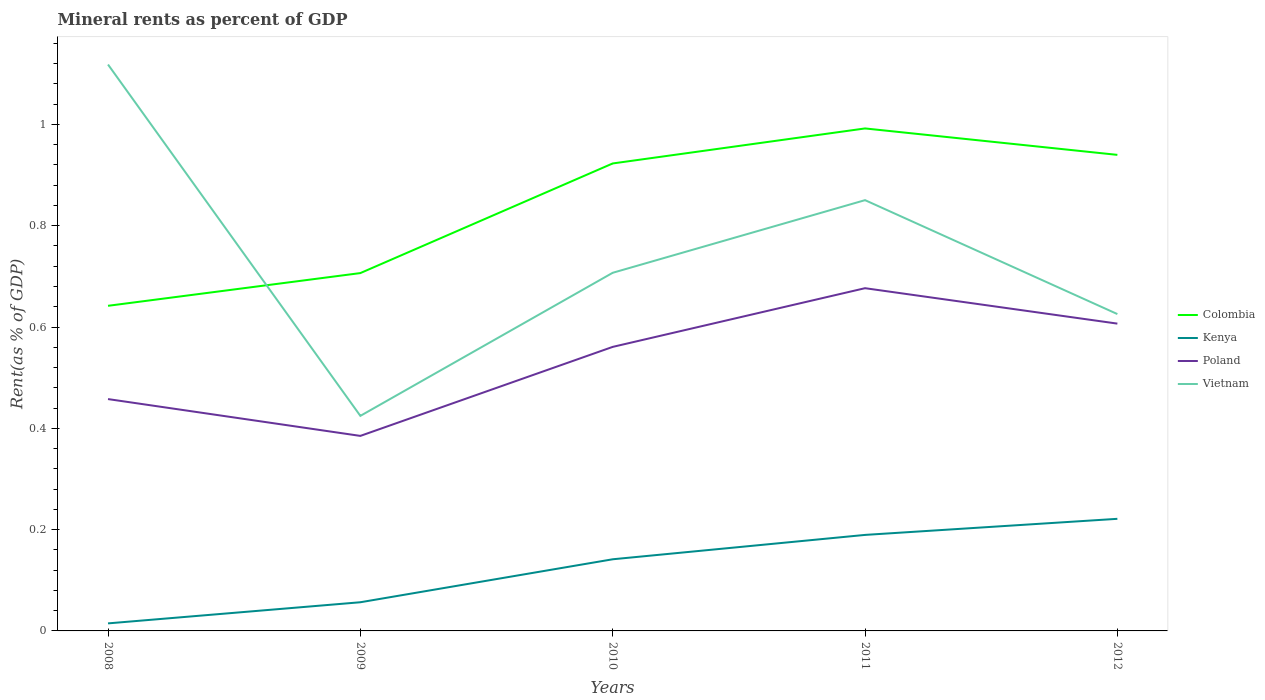How many different coloured lines are there?
Your answer should be compact. 4. Is the number of lines equal to the number of legend labels?
Give a very brief answer. Yes. Across all years, what is the maximum mineral rent in Poland?
Give a very brief answer. 0.39. What is the total mineral rent in Poland in the graph?
Make the answer very short. -0.29. What is the difference between the highest and the second highest mineral rent in Vietnam?
Provide a succinct answer. 0.69. How many years are there in the graph?
Provide a short and direct response. 5. Does the graph contain any zero values?
Keep it short and to the point. No. How many legend labels are there?
Offer a very short reply. 4. How are the legend labels stacked?
Offer a terse response. Vertical. What is the title of the graph?
Make the answer very short. Mineral rents as percent of GDP. Does "United Kingdom" appear as one of the legend labels in the graph?
Your answer should be compact. No. What is the label or title of the Y-axis?
Give a very brief answer. Rent(as % of GDP). What is the Rent(as % of GDP) of Colombia in 2008?
Keep it short and to the point. 0.64. What is the Rent(as % of GDP) of Kenya in 2008?
Give a very brief answer. 0.01. What is the Rent(as % of GDP) of Poland in 2008?
Provide a short and direct response. 0.46. What is the Rent(as % of GDP) of Vietnam in 2008?
Keep it short and to the point. 1.12. What is the Rent(as % of GDP) of Colombia in 2009?
Your answer should be compact. 0.71. What is the Rent(as % of GDP) of Kenya in 2009?
Your answer should be very brief. 0.06. What is the Rent(as % of GDP) of Poland in 2009?
Offer a terse response. 0.39. What is the Rent(as % of GDP) of Vietnam in 2009?
Offer a very short reply. 0.42. What is the Rent(as % of GDP) in Colombia in 2010?
Provide a short and direct response. 0.92. What is the Rent(as % of GDP) in Kenya in 2010?
Offer a very short reply. 0.14. What is the Rent(as % of GDP) of Poland in 2010?
Make the answer very short. 0.56. What is the Rent(as % of GDP) in Vietnam in 2010?
Make the answer very short. 0.71. What is the Rent(as % of GDP) in Colombia in 2011?
Provide a short and direct response. 0.99. What is the Rent(as % of GDP) in Kenya in 2011?
Make the answer very short. 0.19. What is the Rent(as % of GDP) of Poland in 2011?
Give a very brief answer. 0.68. What is the Rent(as % of GDP) in Vietnam in 2011?
Offer a terse response. 0.85. What is the Rent(as % of GDP) in Colombia in 2012?
Give a very brief answer. 0.94. What is the Rent(as % of GDP) in Kenya in 2012?
Your answer should be very brief. 0.22. What is the Rent(as % of GDP) in Poland in 2012?
Your response must be concise. 0.61. What is the Rent(as % of GDP) of Vietnam in 2012?
Your answer should be compact. 0.63. Across all years, what is the maximum Rent(as % of GDP) in Colombia?
Ensure brevity in your answer.  0.99. Across all years, what is the maximum Rent(as % of GDP) of Kenya?
Make the answer very short. 0.22. Across all years, what is the maximum Rent(as % of GDP) of Poland?
Ensure brevity in your answer.  0.68. Across all years, what is the maximum Rent(as % of GDP) in Vietnam?
Your response must be concise. 1.12. Across all years, what is the minimum Rent(as % of GDP) in Colombia?
Provide a short and direct response. 0.64. Across all years, what is the minimum Rent(as % of GDP) of Kenya?
Provide a short and direct response. 0.01. Across all years, what is the minimum Rent(as % of GDP) of Poland?
Give a very brief answer. 0.39. Across all years, what is the minimum Rent(as % of GDP) in Vietnam?
Offer a very short reply. 0.42. What is the total Rent(as % of GDP) of Colombia in the graph?
Offer a terse response. 4.2. What is the total Rent(as % of GDP) of Kenya in the graph?
Offer a terse response. 0.62. What is the total Rent(as % of GDP) in Poland in the graph?
Offer a very short reply. 2.69. What is the total Rent(as % of GDP) of Vietnam in the graph?
Your answer should be very brief. 3.73. What is the difference between the Rent(as % of GDP) of Colombia in 2008 and that in 2009?
Your response must be concise. -0.06. What is the difference between the Rent(as % of GDP) of Kenya in 2008 and that in 2009?
Offer a very short reply. -0.04. What is the difference between the Rent(as % of GDP) in Poland in 2008 and that in 2009?
Your answer should be very brief. 0.07. What is the difference between the Rent(as % of GDP) of Vietnam in 2008 and that in 2009?
Keep it short and to the point. 0.69. What is the difference between the Rent(as % of GDP) of Colombia in 2008 and that in 2010?
Keep it short and to the point. -0.28. What is the difference between the Rent(as % of GDP) in Kenya in 2008 and that in 2010?
Offer a terse response. -0.13. What is the difference between the Rent(as % of GDP) in Poland in 2008 and that in 2010?
Offer a very short reply. -0.1. What is the difference between the Rent(as % of GDP) of Vietnam in 2008 and that in 2010?
Ensure brevity in your answer.  0.41. What is the difference between the Rent(as % of GDP) in Colombia in 2008 and that in 2011?
Offer a very short reply. -0.35. What is the difference between the Rent(as % of GDP) in Kenya in 2008 and that in 2011?
Offer a terse response. -0.17. What is the difference between the Rent(as % of GDP) of Poland in 2008 and that in 2011?
Offer a very short reply. -0.22. What is the difference between the Rent(as % of GDP) in Vietnam in 2008 and that in 2011?
Your answer should be very brief. 0.27. What is the difference between the Rent(as % of GDP) in Colombia in 2008 and that in 2012?
Offer a very short reply. -0.3. What is the difference between the Rent(as % of GDP) of Kenya in 2008 and that in 2012?
Ensure brevity in your answer.  -0.21. What is the difference between the Rent(as % of GDP) of Poland in 2008 and that in 2012?
Offer a very short reply. -0.15. What is the difference between the Rent(as % of GDP) in Vietnam in 2008 and that in 2012?
Offer a very short reply. 0.49. What is the difference between the Rent(as % of GDP) of Colombia in 2009 and that in 2010?
Give a very brief answer. -0.22. What is the difference between the Rent(as % of GDP) in Kenya in 2009 and that in 2010?
Ensure brevity in your answer.  -0.08. What is the difference between the Rent(as % of GDP) in Poland in 2009 and that in 2010?
Ensure brevity in your answer.  -0.18. What is the difference between the Rent(as % of GDP) of Vietnam in 2009 and that in 2010?
Provide a short and direct response. -0.28. What is the difference between the Rent(as % of GDP) in Colombia in 2009 and that in 2011?
Ensure brevity in your answer.  -0.29. What is the difference between the Rent(as % of GDP) of Kenya in 2009 and that in 2011?
Offer a very short reply. -0.13. What is the difference between the Rent(as % of GDP) in Poland in 2009 and that in 2011?
Offer a terse response. -0.29. What is the difference between the Rent(as % of GDP) of Vietnam in 2009 and that in 2011?
Provide a succinct answer. -0.43. What is the difference between the Rent(as % of GDP) of Colombia in 2009 and that in 2012?
Provide a short and direct response. -0.23. What is the difference between the Rent(as % of GDP) in Kenya in 2009 and that in 2012?
Give a very brief answer. -0.16. What is the difference between the Rent(as % of GDP) of Poland in 2009 and that in 2012?
Keep it short and to the point. -0.22. What is the difference between the Rent(as % of GDP) of Vietnam in 2009 and that in 2012?
Offer a terse response. -0.2. What is the difference between the Rent(as % of GDP) of Colombia in 2010 and that in 2011?
Give a very brief answer. -0.07. What is the difference between the Rent(as % of GDP) of Kenya in 2010 and that in 2011?
Your answer should be very brief. -0.05. What is the difference between the Rent(as % of GDP) of Poland in 2010 and that in 2011?
Keep it short and to the point. -0.12. What is the difference between the Rent(as % of GDP) of Vietnam in 2010 and that in 2011?
Offer a terse response. -0.14. What is the difference between the Rent(as % of GDP) in Colombia in 2010 and that in 2012?
Keep it short and to the point. -0.02. What is the difference between the Rent(as % of GDP) in Kenya in 2010 and that in 2012?
Offer a very short reply. -0.08. What is the difference between the Rent(as % of GDP) of Poland in 2010 and that in 2012?
Your answer should be compact. -0.05. What is the difference between the Rent(as % of GDP) of Vietnam in 2010 and that in 2012?
Your response must be concise. 0.08. What is the difference between the Rent(as % of GDP) of Colombia in 2011 and that in 2012?
Your answer should be very brief. 0.05. What is the difference between the Rent(as % of GDP) in Kenya in 2011 and that in 2012?
Keep it short and to the point. -0.03. What is the difference between the Rent(as % of GDP) of Poland in 2011 and that in 2012?
Offer a very short reply. 0.07. What is the difference between the Rent(as % of GDP) of Vietnam in 2011 and that in 2012?
Offer a very short reply. 0.22. What is the difference between the Rent(as % of GDP) in Colombia in 2008 and the Rent(as % of GDP) in Kenya in 2009?
Your answer should be compact. 0.59. What is the difference between the Rent(as % of GDP) in Colombia in 2008 and the Rent(as % of GDP) in Poland in 2009?
Provide a succinct answer. 0.26. What is the difference between the Rent(as % of GDP) of Colombia in 2008 and the Rent(as % of GDP) of Vietnam in 2009?
Offer a terse response. 0.22. What is the difference between the Rent(as % of GDP) in Kenya in 2008 and the Rent(as % of GDP) in Poland in 2009?
Your answer should be very brief. -0.37. What is the difference between the Rent(as % of GDP) in Kenya in 2008 and the Rent(as % of GDP) in Vietnam in 2009?
Provide a succinct answer. -0.41. What is the difference between the Rent(as % of GDP) in Poland in 2008 and the Rent(as % of GDP) in Vietnam in 2009?
Your answer should be compact. 0.03. What is the difference between the Rent(as % of GDP) in Colombia in 2008 and the Rent(as % of GDP) in Kenya in 2010?
Your answer should be compact. 0.5. What is the difference between the Rent(as % of GDP) in Colombia in 2008 and the Rent(as % of GDP) in Poland in 2010?
Give a very brief answer. 0.08. What is the difference between the Rent(as % of GDP) of Colombia in 2008 and the Rent(as % of GDP) of Vietnam in 2010?
Keep it short and to the point. -0.07. What is the difference between the Rent(as % of GDP) in Kenya in 2008 and the Rent(as % of GDP) in Poland in 2010?
Give a very brief answer. -0.55. What is the difference between the Rent(as % of GDP) in Kenya in 2008 and the Rent(as % of GDP) in Vietnam in 2010?
Your answer should be very brief. -0.69. What is the difference between the Rent(as % of GDP) of Poland in 2008 and the Rent(as % of GDP) of Vietnam in 2010?
Provide a short and direct response. -0.25. What is the difference between the Rent(as % of GDP) in Colombia in 2008 and the Rent(as % of GDP) in Kenya in 2011?
Ensure brevity in your answer.  0.45. What is the difference between the Rent(as % of GDP) in Colombia in 2008 and the Rent(as % of GDP) in Poland in 2011?
Offer a very short reply. -0.03. What is the difference between the Rent(as % of GDP) of Colombia in 2008 and the Rent(as % of GDP) of Vietnam in 2011?
Your answer should be very brief. -0.21. What is the difference between the Rent(as % of GDP) in Kenya in 2008 and the Rent(as % of GDP) in Poland in 2011?
Your response must be concise. -0.66. What is the difference between the Rent(as % of GDP) of Kenya in 2008 and the Rent(as % of GDP) of Vietnam in 2011?
Give a very brief answer. -0.84. What is the difference between the Rent(as % of GDP) in Poland in 2008 and the Rent(as % of GDP) in Vietnam in 2011?
Your answer should be compact. -0.39. What is the difference between the Rent(as % of GDP) in Colombia in 2008 and the Rent(as % of GDP) in Kenya in 2012?
Make the answer very short. 0.42. What is the difference between the Rent(as % of GDP) of Colombia in 2008 and the Rent(as % of GDP) of Poland in 2012?
Make the answer very short. 0.04. What is the difference between the Rent(as % of GDP) of Colombia in 2008 and the Rent(as % of GDP) of Vietnam in 2012?
Your answer should be compact. 0.02. What is the difference between the Rent(as % of GDP) of Kenya in 2008 and the Rent(as % of GDP) of Poland in 2012?
Offer a terse response. -0.59. What is the difference between the Rent(as % of GDP) of Kenya in 2008 and the Rent(as % of GDP) of Vietnam in 2012?
Give a very brief answer. -0.61. What is the difference between the Rent(as % of GDP) of Poland in 2008 and the Rent(as % of GDP) of Vietnam in 2012?
Your answer should be very brief. -0.17. What is the difference between the Rent(as % of GDP) in Colombia in 2009 and the Rent(as % of GDP) in Kenya in 2010?
Offer a very short reply. 0.56. What is the difference between the Rent(as % of GDP) in Colombia in 2009 and the Rent(as % of GDP) in Poland in 2010?
Make the answer very short. 0.15. What is the difference between the Rent(as % of GDP) in Colombia in 2009 and the Rent(as % of GDP) in Vietnam in 2010?
Your answer should be very brief. -0. What is the difference between the Rent(as % of GDP) of Kenya in 2009 and the Rent(as % of GDP) of Poland in 2010?
Offer a terse response. -0.5. What is the difference between the Rent(as % of GDP) of Kenya in 2009 and the Rent(as % of GDP) of Vietnam in 2010?
Make the answer very short. -0.65. What is the difference between the Rent(as % of GDP) of Poland in 2009 and the Rent(as % of GDP) of Vietnam in 2010?
Your answer should be very brief. -0.32. What is the difference between the Rent(as % of GDP) of Colombia in 2009 and the Rent(as % of GDP) of Kenya in 2011?
Offer a terse response. 0.52. What is the difference between the Rent(as % of GDP) in Colombia in 2009 and the Rent(as % of GDP) in Poland in 2011?
Give a very brief answer. 0.03. What is the difference between the Rent(as % of GDP) of Colombia in 2009 and the Rent(as % of GDP) of Vietnam in 2011?
Make the answer very short. -0.14. What is the difference between the Rent(as % of GDP) in Kenya in 2009 and the Rent(as % of GDP) in Poland in 2011?
Give a very brief answer. -0.62. What is the difference between the Rent(as % of GDP) of Kenya in 2009 and the Rent(as % of GDP) of Vietnam in 2011?
Your answer should be very brief. -0.79. What is the difference between the Rent(as % of GDP) in Poland in 2009 and the Rent(as % of GDP) in Vietnam in 2011?
Your answer should be very brief. -0.47. What is the difference between the Rent(as % of GDP) in Colombia in 2009 and the Rent(as % of GDP) in Kenya in 2012?
Provide a short and direct response. 0.49. What is the difference between the Rent(as % of GDP) of Colombia in 2009 and the Rent(as % of GDP) of Poland in 2012?
Provide a succinct answer. 0.1. What is the difference between the Rent(as % of GDP) in Colombia in 2009 and the Rent(as % of GDP) in Vietnam in 2012?
Ensure brevity in your answer.  0.08. What is the difference between the Rent(as % of GDP) of Kenya in 2009 and the Rent(as % of GDP) of Poland in 2012?
Provide a short and direct response. -0.55. What is the difference between the Rent(as % of GDP) of Kenya in 2009 and the Rent(as % of GDP) of Vietnam in 2012?
Give a very brief answer. -0.57. What is the difference between the Rent(as % of GDP) in Poland in 2009 and the Rent(as % of GDP) in Vietnam in 2012?
Ensure brevity in your answer.  -0.24. What is the difference between the Rent(as % of GDP) in Colombia in 2010 and the Rent(as % of GDP) in Kenya in 2011?
Your answer should be compact. 0.73. What is the difference between the Rent(as % of GDP) of Colombia in 2010 and the Rent(as % of GDP) of Poland in 2011?
Your answer should be compact. 0.25. What is the difference between the Rent(as % of GDP) of Colombia in 2010 and the Rent(as % of GDP) of Vietnam in 2011?
Offer a very short reply. 0.07. What is the difference between the Rent(as % of GDP) of Kenya in 2010 and the Rent(as % of GDP) of Poland in 2011?
Ensure brevity in your answer.  -0.54. What is the difference between the Rent(as % of GDP) of Kenya in 2010 and the Rent(as % of GDP) of Vietnam in 2011?
Offer a very short reply. -0.71. What is the difference between the Rent(as % of GDP) in Poland in 2010 and the Rent(as % of GDP) in Vietnam in 2011?
Your answer should be very brief. -0.29. What is the difference between the Rent(as % of GDP) in Colombia in 2010 and the Rent(as % of GDP) in Kenya in 2012?
Your answer should be very brief. 0.7. What is the difference between the Rent(as % of GDP) of Colombia in 2010 and the Rent(as % of GDP) of Poland in 2012?
Make the answer very short. 0.32. What is the difference between the Rent(as % of GDP) in Colombia in 2010 and the Rent(as % of GDP) in Vietnam in 2012?
Give a very brief answer. 0.3. What is the difference between the Rent(as % of GDP) of Kenya in 2010 and the Rent(as % of GDP) of Poland in 2012?
Make the answer very short. -0.47. What is the difference between the Rent(as % of GDP) of Kenya in 2010 and the Rent(as % of GDP) of Vietnam in 2012?
Provide a succinct answer. -0.48. What is the difference between the Rent(as % of GDP) of Poland in 2010 and the Rent(as % of GDP) of Vietnam in 2012?
Give a very brief answer. -0.06. What is the difference between the Rent(as % of GDP) in Colombia in 2011 and the Rent(as % of GDP) in Kenya in 2012?
Your answer should be compact. 0.77. What is the difference between the Rent(as % of GDP) in Colombia in 2011 and the Rent(as % of GDP) in Poland in 2012?
Ensure brevity in your answer.  0.39. What is the difference between the Rent(as % of GDP) of Colombia in 2011 and the Rent(as % of GDP) of Vietnam in 2012?
Provide a short and direct response. 0.37. What is the difference between the Rent(as % of GDP) in Kenya in 2011 and the Rent(as % of GDP) in Poland in 2012?
Ensure brevity in your answer.  -0.42. What is the difference between the Rent(as % of GDP) of Kenya in 2011 and the Rent(as % of GDP) of Vietnam in 2012?
Your answer should be very brief. -0.44. What is the difference between the Rent(as % of GDP) of Poland in 2011 and the Rent(as % of GDP) of Vietnam in 2012?
Provide a short and direct response. 0.05. What is the average Rent(as % of GDP) in Colombia per year?
Your answer should be very brief. 0.84. What is the average Rent(as % of GDP) in Kenya per year?
Offer a terse response. 0.12. What is the average Rent(as % of GDP) of Poland per year?
Your answer should be compact. 0.54. What is the average Rent(as % of GDP) of Vietnam per year?
Your response must be concise. 0.75. In the year 2008, what is the difference between the Rent(as % of GDP) of Colombia and Rent(as % of GDP) of Kenya?
Offer a very short reply. 0.63. In the year 2008, what is the difference between the Rent(as % of GDP) of Colombia and Rent(as % of GDP) of Poland?
Your answer should be compact. 0.18. In the year 2008, what is the difference between the Rent(as % of GDP) in Colombia and Rent(as % of GDP) in Vietnam?
Ensure brevity in your answer.  -0.48. In the year 2008, what is the difference between the Rent(as % of GDP) of Kenya and Rent(as % of GDP) of Poland?
Provide a short and direct response. -0.44. In the year 2008, what is the difference between the Rent(as % of GDP) of Kenya and Rent(as % of GDP) of Vietnam?
Ensure brevity in your answer.  -1.1. In the year 2008, what is the difference between the Rent(as % of GDP) in Poland and Rent(as % of GDP) in Vietnam?
Give a very brief answer. -0.66. In the year 2009, what is the difference between the Rent(as % of GDP) of Colombia and Rent(as % of GDP) of Kenya?
Ensure brevity in your answer.  0.65. In the year 2009, what is the difference between the Rent(as % of GDP) of Colombia and Rent(as % of GDP) of Poland?
Provide a succinct answer. 0.32. In the year 2009, what is the difference between the Rent(as % of GDP) of Colombia and Rent(as % of GDP) of Vietnam?
Keep it short and to the point. 0.28. In the year 2009, what is the difference between the Rent(as % of GDP) of Kenya and Rent(as % of GDP) of Poland?
Offer a terse response. -0.33. In the year 2009, what is the difference between the Rent(as % of GDP) of Kenya and Rent(as % of GDP) of Vietnam?
Make the answer very short. -0.37. In the year 2009, what is the difference between the Rent(as % of GDP) of Poland and Rent(as % of GDP) of Vietnam?
Give a very brief answer. -0.04. In the year 2010, what is the difference between the Rent(as % of GDP) in Colombia and Rent(as % of GDP) in Kenya?
Give a very brief answer. 0.78. In the year 2010, what is the difference between the Rent(as % of GDP) in Colombia and Rent(as % of GDP) in Poland?
Your answer should be very brief. 0.36. In the year 2010, what is the difference between the Rent(as % of GDP) in Colombia and Rent(as % of GDP) in Vietnam?
Your answer should be compact. 0.22. In the year 2010, what is the difference between the Rent(as % of GDP) in Kenya and Rent(as % of GDP) in Poland?
Offer a very short reply. -0.42. In the year 2010, what is the difference between the Rent(as % of GDP) in Kenya and Rent(as % of GDP) in Vietnam?
Offer a very short reply. -0.57. In the year 2010, what is the difference between the Rent(as % of GDP) in Poland and Rent(as % of GDP) in Vietnam?
Make the answer very short. -0.15. In the year 2011, what is the difference between the Rent(as % of GDP) in Colombia and Rent(as % of GDP) in Kenya?
Your answer should be very brief. 0.8. In the year 2011, what is the difference between the Rent(as % of GDP) in Colombia and Rent(as % of GDP) in Poland?
Your response must be concise. 0.32. In the year 2011, what is the difference between the Rent(as % of GDP) of Colombia and Rent(as % of GDP) of Vietnam?
Provide a succinct answer. 0.14. In the year 2011, what is the difference between the Rent(as % of GDP) in Kenya and Rent(as % of GDP) in Poland?
Offer a very short reply. -0.49. In the year 2011, what is the difference between the Rent(as % of GDP) in Kenya and Rent(as % of GDP) in Vietnam?
Keep it short and to the point. -0.66. In the year 2011, what is the difference between the Rent(as % of GDP) of Poland and Rent(as % of GDP) of Vietnam?
Ensure brevity in your answer.  -0.17. In the year 2012, what is the difference between the Rent(as % of GDP) in Colombia and Rent(as % of GDP) in Kenya?
Offer a very short reply. 0.72. In the year 2012, what is the difference between the Rent(as % of GDP) in Colombia and Rent(as % of GDP) in Poland?
Your answer should be very brief. 0.33. In the year 2012, what is the difference between the Rent(as % of GDP) in Colombia and Rent(as % of GDP) in Vietnam?
Provide a succinct answer. 0.31. In the year 2012, what is the difference between the Rent(as % of GDP) in Kenya and Rent(as % of GDP) in Poland?
Your answer should be compact. -0.39. In the year 2012, what is the difference between the Rent(as % of GDP) in Kenya and Rent(as % of GDP) in Vietnam?
Make the answer very short. -0.4. In the year 2012, what is the difference between the Rent(as % of GDP) in Poland and Rent(as % of GDP) in Vietnam?
Offer a very short reply. -0.02. What is the ratio of the Rent(as % of GDP) of Colombia in 2008 to that in 2009?
Offer a terse response. 0.91. What is the ratio of the Rent(as % of GDP) of Kenya in 2008 to that in 2009?
Your response must be concise. 0.26. What is the ratio of the Rent(as % of GDP) in Poland in 2008 to that in 2009?
Make the answer very short. 1.19. What is the ratio of the Rent(as % of GDP) in Vietnam in 2008 to that in 2009?
Keep it short and to the point. 2.63. What is the ratio of the Rent(as % of GDP) in Colombia in 2008 to that in 2010?
Ensure brevity in your answer.  0.7. What is the ratio of the Rent(as % of GDP) of Kenya in 2008 to that in 2010?
Give a very brief answer. 0.11. What is the ratio of the Rent(as % of GDP) in Poland in 2008 to that in 2010?
Your answer should be very brief. 0.82. What is the ratio of the Rent(as % of GDP) of Vietnam in 2008 to that in 2010?
Your answer should be compact. 1.58. What is the ratio of the Rent(as % of GDP) in Colombia in 2008 to that in 2011?
Offer a terse response. 0.65. What is the ratio of the Rent(as % of GDP) in Kenya in 2008 to that in 2011?
Provide a short and direct response. 0.08. What is the ratio of the Rent(as % of GDP) of Poland in 2008 to that in 2011?
Give a very brief answer. 0.68. What is the ratio of the Rent(as % of GDP) in Vietnam in 2008 to that in 2011?
Ensure brevity in your answer.  1.31. What is the ratio of the Rent(as % of GDP) in Colombia in 2008 to that in 2012?
Ensure brevity in your answer.  0.68. What is the ratio of the Rent(as % of GDP) in Kenya in 2008 to that in 2012?
Provide a succinct answer. 0.07. What is the ratio of the Rent(as % of GDP) in Poland in 2008 to that in 2012?
Your response must be concise. 0.75. What is the ratio of the Rent(as % of GDP) of Vietnam in 2008 to that in 2012?
Your response must be concise. 1.79. What is the ratio of the Rent(as % of GDP) in Colombia in 2009 to that in 2010?
Ensure brevity in your answer.  0.77. What is the ratio of the Rent(as % of GDP) in Kenya in 2009 to that in 2010?
Make the answer very short. 0.4. What is the ratio of the Rent(as % of GDP) of Poland in 2009 to that in 2010?
Provide a succinct answer. 0.69. What is the ratio of the Rent(as % of GDP) of Vietnam in 2009 to that in 2010?
Provide a short and direct response. 0.6. What is the ratio of the Rent(as % of GDP) of Colombia in 2009 to that in 2011?
Your response must be concise. 0.71. What is the ratio of the Rent(as % of GDP) of Kenya in 2009 to that in 2011?
Your response must be concise. 0.3. What is the ratio of the Rent(as % of GDP) in Poland in 2009 to that in 2011?
Provide a succinct answer. 0.57. What is the ratio of the Rent(as % of GDP) in Vietnam in 2009 to that in 2011?
Your answer should be compact. 0.5. What is the ratio of the Rent(as % of GDP) in Colombia in 2009 to that in 2012?
Keep it short and to the point. 0.75. What is the ratio of the Rent(as % of GDP) in Kenya in 2009 to that in 2012?
Your response must be concise. 0.26. What is the ratio of the Rent(as % of GDP) of Poland in 2009 to that in 2012?
Your answer should be very brief. 0.63. What is the ratio of the Rent(as % of GDP) in Vietnam in 2009 to that in 2012?
Your answer should be compact. 0.68. What is the ratio of the Rent(as % of GDP) of Colombia in 2010 to that in 2011?
Offer a very short reply. 0.93. What is the ratio of the Rent(as % of GDP) of Kenya in 2010 to that in 2011?
Your response must be concise. 0.75. What is the ratio of the Rent(as % of GDP) of Poland in 2010 to that in 2011?
Offer a terse response. 0.83. What is the ratio of the Rent(as % of GDP) in Vietnam in 2010 to that in 2011?
Ensure brevity in your answer.  0.83. What is the ratio of the Rent(as % of GDP) of Colombia in 2010 to that in 2012?
Offer a terse response. 0.98. What is the ratio of the Rent(as % of GDP) in Kenya in 2010 to that in 2012?
Provide a short and direct response. 0.64. What is the ratio of the Rent(as % of GDP) of Poland in 2010 to that in 2012?
Provide a short and direct response. 0.92. What is the ratio of the Rent(as % of GDP) of Vietnam in 2010 to that in 2012?
Offer a very short reply. 1.13. What is the ratio of the Rent(as % of GDP) of Colombia in 2011 to that in 2012?
Make the answer very short. 1.06. What is the ratio of the Rent(as % of GDP) of Kenya in 2011 to that in 2012?
Offer a terse response. 0.86. What is the ratio of the Rent(as % of GDP) of Poland in 2011 to that in 2012?
Provide a short and direct response. 1.12. What is the ratio of the Rent(as % of GDP) of Vietnam in 2011 to that in 2012?
Ensure brevity in your answer.  1.36. What is the difference between the highest and the second highest Rent(as % of GDP) of Colombia?
Make the answer very short. 0.05. What is the difference between the highest and the second highest Rent(as % of GDP) in Kenya?
Your answer should be compact. 0.03. What is the difference between the highest and the second highest Rent(as % of GDP) of Poland?
Your answer should be compact. 0.07. What is the difference between the highest and the second highest Rent(as % of GDP) in Vietnam?
Your answer should be compact. 0.27. What is the difference between the highest and the lowest Rent(as % of GDP) in Colombia?
Provide a short and direct response. 0.35. What is the difference between the highest and the lowest Rent(as % of GDP) of Kenya?
Make the answer very short. 0.21. What is the difference between the highest and the lowest Rent(as % of GDP) of Poland?
Provide a short and direct response. 0.29. What is the difference between the highest and the lowest Rent(as % of GDP) of Vietnam?
Your answer should be very brief. 0.69. 